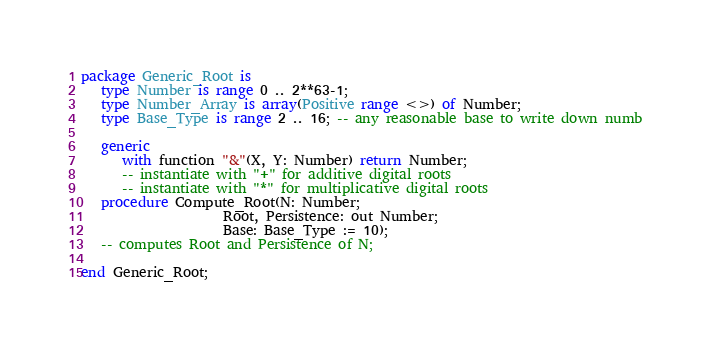<code> <loc_0><loc_0><loc_500><loc_500><_Ada_>package Generic_Root is
   type Number is range 0 .. 2**63-1;
   type Number_Array is array(Positive range <>) of Number;
   type Base_Type is range 2 .. 16; -- any reasonable base to write down numb

   generic
      with function "&"(X, Y: Number) return Number;
      -- instantiate with "+" for additive digital roots
      -- instantiate with "*" for multiplicative digital roots
   procedure Compute_Root(N: Number;
                     Root, Persistence: out Number;
                     Base: Base_Type := 10);
   -- computes Root and Persistence of N;

end Generic_Root;
</code> 